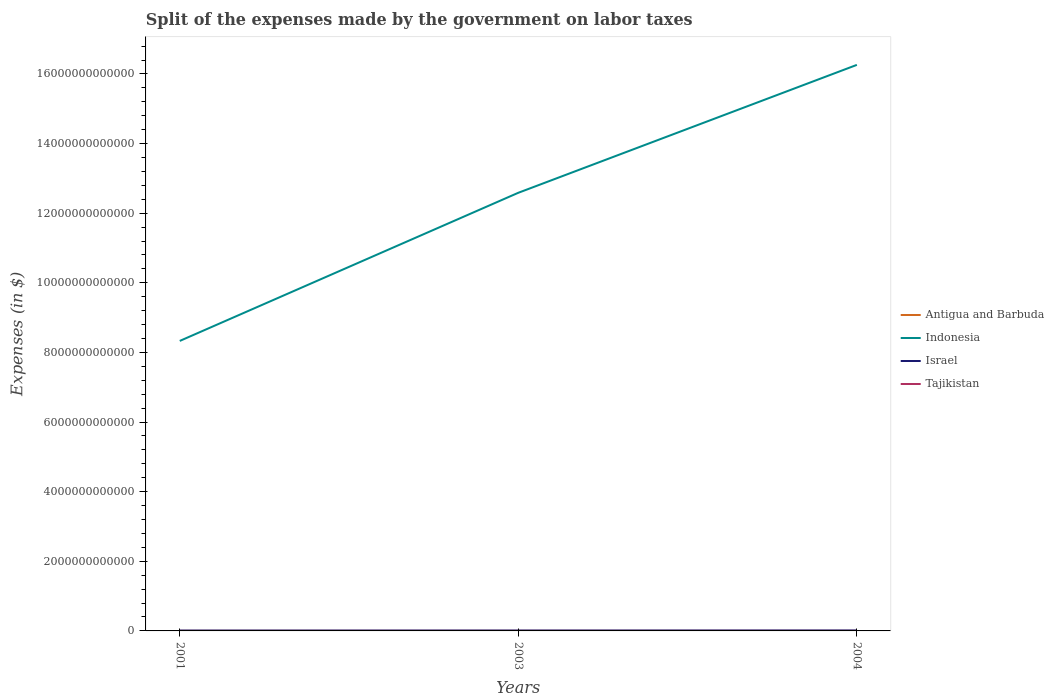How many different coloured lines are there?
Ensure brevity in your answer.  4. Does the line corresponding to Antigua and Barbuda intersect with the line corresponding to Tajikistan?
Offer a very short reply. Yes. Is the number of lines equal to the number of legend labels?
Your response must be concise. Yes. Across all years, what is the maximum expenses made by the government on labor taxes in Indonesia?
Offer a terse response. 8.33e+12. In which year was the expenses made by the government on labor taxes in Tajikistan maximum?
Your answer should be compact. 2001. What is the total expenses made by the government on labor taxes in Israel in the graph?
Keep it short and to the point. -1.24e+09. What is the difference between the highest and the second highest expenses made by the government on labor taxes in Israel?
Your answer should be very brief. 2.76e+09. What is the difference between the highest and the lowest expenses made by the government on labor taxes in Israel?
Your response must be concise. 1. How many lines are there?
Keep it short and to the point. 4. How many years are there in the graph?
Make the answer very short. 3. What is the difference between two consecutive major ticks on the Y-axis?
Give a very brief answer. 2.00e+12. Are the values on the major ticks of Y-axis written in scientific E-notation?
Offer a very short reply. No. Does the graph contain grids?
Make the answer very short. No. Where does the legend appear in the graph?
Offer a very short reply. Center right. How many legend labels are there?
Offer a very short reply. 4. How are the legend labels stacked?
Offer a very short reply. Vertical. What is the title of the graph?
Provide a succinct answer. Split of the expenses made by the government on labor taxes. Does "Uruguay" appear as one of the legend labels in the graph?
Give a very brief answer. No. What is the label or title of the X-axis?
Give a very brief answer. Years. What is the label or title of the Y-axis?
Your answer should be very brief. Expenses (in $). What is the Expenses (in $) in Indonesia in 2001?
Make the answer very short. 8.33e+12. What is the Expenses (in $) of Israel in 2001?
Your answer should be very brief. 1.06e+1. What is the Expenses (in $) in Tajikistan in 2001?
Keep it short and to the point. 3.17e+06. What is the Expenses (in $) of Antigua and Barbuda in 2003?
Give a very brief answer. 1.11e+07. What is the Expenses (in $) in Indonesia in 2003?
Provide a short and direct response. 1.26e+13. What is the Expenses (in $) in Israel in 2003?
Your response must be concise. 1.19e+1. What is the Expenses (in $) of Tajikistan in 2003?
Your response must be concise. 7.63e+06. What is the Expenses (in $) of Antigua and Barbuda in 2004?
Your answer should be very brief. 1.00e+07. What is the Expenses (in $) in Indonesia in 2004?
Make the answer very short. 1.63e+13. What is the Expenses (in $) of Israel in 2004?
Ensure brevity in your answer.  1.34e+1. What is the Expenses (in $) of Tajikistan in 2004?
Keep it short and to the point. 1.14e+07. Across all years, what is the maximum Expenses (in $) in Antigua and Barbuda?
Offer a very short reply. 1.11e+07. Across all years, what is the maximum Expenses (in $) of Indonesia?
Keep it short and to the point. 1.63e+13. Across all years, what is the maximum Expenses (in $) in Israel?
Offer a terse response. 1.34e+1. Across all years, what is the maximum Expenses (in $) of Tajikistan?
Keep it short and to the point. 1.14e+07. Across all years, what is the minimum Expenses (in $) in Antigua and Barbuda?
Keep it short and to the point. 6.00e+06. Across all years, what is the minimum Expenses (in $) of Indonesia?
Offer a very short reply. 8.33e+12. Across all years, what is the minimum Expenses (in $) of Israel?
Keep it short and to the point. 1.06e+1. Across all years, what is the minimum Expenses (in $) in Tajikistan?
Give a very brief answer. 3.17e+06. What is the total Expenses (in $) in Antigua and Barbuda in the graph?
Provide a succinct answer. 2.71e+07. What is the total Expenses (in $) in Indonesia in the graph?
Give a very brief answer. 3.72e+13. What is the total Expenses (in $) of Israel in the graph?
Give a very brief answer. 3.58e+1. What is the total Expenses (in $) of Tajikistan in the graph?
Offer a terse response. 2.22e+07. What is the difference between the Expenses (in $) of Antigua and Barbuda in 2001 and that in 2003?
Give a very brief answer. -5.10e+06. What is the difference between the Expenses (in $) in Indonesia in 2001 and that in 2003?
Ensure brevity in your answer.  -4.26e+12. What is the difference between the Expenses (in $) in Israel in 2001 and that in 2003?
Ensure brevity in your answer.  -1.24e+09. What is the difference between the Expenses (in $) in Tajikistan in 2001 and that in 2003?
Your answer should be very brief. -4.46e+06. What is the difference between the Expenses (in $) in Indonesia in 2001 and that in 2004?
Ensure brevity in your answer.  -7.93e+12. What is the difference between the Expenses (in $) of Israel in 2001 and that in 2004?
Your answer should be very brief. -2.76e+09. What is the difference between the Expenses (in $) of Tajikistan in 2001 and that in 2004?
Offer a terse response. -8.18e+06. What is the difference between the Expenses (in $) of Antigua and Barbuda in 2003 and that in 2004?
Offer a terse response. 1.10e+06. What is the difference between the Expenses (in $) in Indonesia in 2003 and that in 2004?
Your answer should be compact. -3.67e+12. What is the difference between the Expenses (in $) in Israel in 2003 and that in 2004?
Your answer should be compact. -1.51e+09. What is the difference between the Expenses (in $) in Tajikistan in 2003 and that in 2004?
Make the answer very short. -3.73e+06. What is the difference between the Expenses (in $) of Antigua and Barbuda in 2001 and the Expenses (in $) of Indonesia in 2003?
Your answer should be very brief. -1.26e+13. What is the difference between the Expenses (in $) in Antigua and Barbuda in 2001 and the Expenses (in $) in Israel in 2003?
Offer a terse response. -1.18e+1. What is the difference between the Expenses (in $) of Antigua and Barbuda in 2001 and the Expenses (in $) of Tajikistan in 2003?
Ensure brevity in your answer.  -1.63e+06. What is the difference between the Expenses (in $) of Indonesia in 2001 and the Expenses (in $) of Israel in 2003?
Ensure brevity in your answer.  8.32e+12. What is the difference between the Expenses (in $) in Indonesia in 2001 and the Expenses (in $) in Tajikistan in 2003?
Your response must be concise. 8.33e+12. What is the difference between the Expenses (in $) in Israel in 2001 and the Expenses (in $) in Tajikistan in 2003?
Ensure brevity in your answer.  1.06e+1. What is the difference between the Expenses (in $) of Antigua and Barbuda in 2001 and the Expenses (in $) of Indonesia in 2004?
Your response must be concise. -1.63e+13. What is the difference between the Expenses (in $) in Antigua and Barbuda in 2001 and the Expenses (in $) in Israel in 2004?
Provide a succinct answer. -1.34e+1. What is the difference between the Expenses (in $) of Antigua and Barbuda in 2001 and the Expenses (in $) of Tajikistan in 2004?
Your response must be concise. -5.36e+06. What is the difference between the Expenses (in $) in Indonesia in 2001 and the Expenses (in $) in Israel in 2004?
Give a very brief answer. 8.32e+12. What is the difference between the Expenses (in $) in Indonesia in 2001 and the Expenses (in $) in Tajikistan in 2004?
Your answer should be very brief. 8.33e+12. What is the difference between the Expenses (in $) of Israel in 2001 and the Expenses (in $) of Tajikistan in 2004?
Ensure brevity in your answer.  1.06e+1. What is the difference between the Expenses (in $) of Antigua and Barbuda in 2003 and the Expenses (in $) of Indonesia in 2004?
Offer a very short reply. -1.63e+13. What is the difference between the Expenses (in $) in Antigua and Barbuda in 2003 and the Expenses (in $) in Israel in 2004?
Keep it short and to the point. -1.34e+1. What is the difference between the Expenses (in $) in Antigua and Barbuda in 2003 and the Expenses (in $) in Tajikistan in 2004?
Ensure brevity in your answer.  -2.55e+05. What is the difference between the Expenses (in $) of Indonesia in 2003 and the Expenses (in $) of Israel in 2004?
Ensure brevity in your answer.  1.26e+13. What is the difference between the Expenses (in $) in Indonesia in 2003 and the Expenses (in $) in Tajikistan in 2004?
Provide a short and direct response. 1.26e+13. What is the difference between the Expenses (in $) of Israel in 2003 and the Expenses (in $) of Tajikistan in 2004?
Provide a short and direct response. 1.18e+1. What is the average Expenses (in $) of Antigua and Barbuda per year?
Give a very brief answer. 9.03e+06. What is the average Expenses (in $) in Indonesia per year?
Ensure brevity in your answer.  1.24e+13. What is the average Expenses (in $) of Israel per year?
Offer a terse response. 1.19e+1. What is the average Expenses (in $) of Tajikistan per year?
Provide a short and direct response. 7.38e+06. In the year 2001, what is the difference between the Expenses (in $) in Antigua and Barbuda and Expenses (in $) in Indonesia?
Your answer should be compact. -8.33e+12. In the year 2001, what is the difference between the Expenses (in $) of Antigua and Barbuda and Expenses (in $) of Israel?
Keep it short and to the point. -1.06e+1. In the year 2001, what is the difference between the Expenses (in $) in Antigua and Barbuda and Expenses (in $) in Tajikistan?
Your answer should be compact. 2.83e+06. In the year 2001, what is the difference between the Expenses (in $) of Indonesia and Expenses (in $) of Israel?
Provide a short and direct response. 8.32e+12. In the year 2001, what is the difference between the Expenses (in $) of Indonesia and Expenses (in $) of Tajikistan?
Provide a short and direct response. 8.33e+12. In the year 2001, what is the difference between the Expenses (in $) of Israel and Expenses (in $) of Tajikistan?
Make the answer very short. 1.06e+1. In the year 2003, what is the difference between the Expenses (in $) of Antigua and Barbuda and Expenses (in $) of Indonesia?
Ensure brevity in your answer.  -1.26e+13. In the year 2003, what is the difference between the Expenses (in $) of Antigua and Barbuda and Expenses (in $) of Israel?
Keep it short and to the point. -1.18e+1. In the year 2003, what is the difference between the Expenses (in $) of Antigua and Barbuda and Expenses (in $) of Tajikistan?
Your response must be concise. 3.47e+06. In the year 2003, what is the difference between the Expenses (in $) of Indonesia and Expenses (in $) of Israel?
Your answer should be compact. 1.26e+13. In the year 2003, what is the difference between the Expenses (in $) of Indonesia and Expenses (in $) of Tajikistan?
Offer a terse response. 1.26e+13. In the year 2003, what is the difference between the Expenses (in $) of Israel and Expenses (in $) of Tajikistan?
Your response must be concise. 1.18e+1. In the year 2004, what is the difference between the Expenses (in $) of Antigua and Barbuda and Expenses (in $) of Indonesia?
Offer a terse response. -1.63e+13. In the year 2004, what is the difference between the Expenses (in $) in Antigua and Barbuda and Expenses (in $) in Israel?
Ensure brevity in your answer.  -1.34e+1. In the year 2004, what is the difference between the Expenses (in $) in Antigua and Barbuda and Expenses (in $) in Tajikistan?
Ensure brevity in your answer.  -1.36e+06. In the year 2004, what is the difference between the Expenses (in $) in Indonesia and Expenses (in $) in Israel?
Provide a succinct answer. 1.62e+13. In the year 2004, what is the difference between the Expenses (in $) in Indonesia and Expenses (in $) in Tajikistan?
Keep it short and to the point. 1.63e+13. In the year 2004, what is the difference between the Expenses (in $) in Israel and Expenses (in $) in Tajikistan?
Offer a very short reply. 1.34e+1. What is the ratio of the Expenses (in $) of Antigua and Barbuda in 2001 to that in 2003?
Offer a very short reply. 0.54. What is the ratio of the Expenses (in $) in Indonesia in 2001 to that in 2003?
Keep it short and to the point. 0.66. What is the ratio of the Expenses (in $) in Israel in 2001 to that in 2003?
Make the answer very short. 0.9. What is the ratio of the Expenses (in $) in Tajikistan in 2001 to that in 2003?
Give a very brief answer. 0.42. What is the ratio of the Expenses (in $) in Indonesia in 2001 to that in 2004?
Ensure brevity in your answer.  0.51. What is the ratio of the Expenses (in $) of Israel in 2001 to that in 2004?
Your answer should be very brief. 0.79. What is the ratio of the Expenses (in $) of Tajikistan in 2001 to that in 2004?
Provide a succinct answer. 0.28. What is the ratio of the Expenses (in $) in Antigua and Barbuda in 2003 to that in 2004?
Provide a succinct answer. 1.11. What is the ratio of the Expenses (in $) of Indonesia in 2003 to that in 2004?
Provide a succinct answer. 0.77. What is the ratio of the Expenses (in $) of Israel in 2003 to that in 2004?
Provide a succinct answer. 0.89. What is the ratio of the Expenses (in $) of Tajikistan in 2003 to that in 2004?
Give a very brief answer. 0.67. What is the difference between the highest and the second highest Expenses (in $) of Antigua and Barbuda?
Keep it short and to the point. 1.10e+06. What is the difference between the highest and the second highest Expenses (in $) of Indonesia?
Your answer should be very brief. 3.67e+12. What is the difference between the highest and the second highest Expenses (in $) of Israel?
Ensure brevity in your answer.  1.51e+09. What is the difference between the highest and the second highest Expenses (in $) in Tajikistan?
Your answer should be compact. 3.73e+06. What is the difference between the highest and the lowest Expenses (in $) of Antigua and Barbuda?
Give a very brief answer. 5.10e+06. What is the difference between the highest and the lowest Expenses (in $) in Indonesia?
Provide a succinct answer. 7.93e+12. What is the difference between the highest and the lowest Expenses (in $) in Israel?
Your answer should be very brief. 2.76e+09. What is the difference between the highest and the lowest Expenses (in $) of Tajikistan?
Your response must be concise. 8.18e+06. 